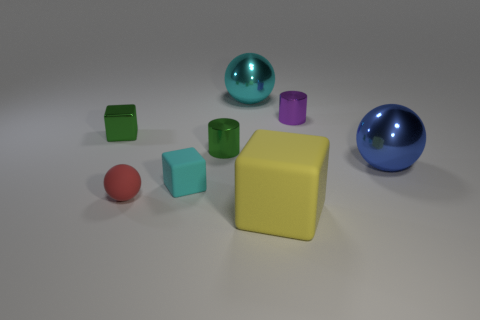Is the small cyan thing made of the same material as the large cube?
Keep it short and to the point. Yes. Is the number of big cyan things on the right side of the yellow object greater than the number of big yellow cubes?
Keep it short and to the point. No. What material is the tiny green thing behind the tiny green metallic thing that is to the right of the small cyan object in front of the cyan ball?
Offer a very short reply. Metal. What number of objects are either cubes or things to the left of the small purple cylinder?
Offer a terse response. 6. There is a big ball that is right of the yellow block; does it have the same color as the shiny block?
Ensure brevity in your answer.  No. Are there more blue shiny spheres that are in front of the red matte ball than small cyan rubber objects that are to the left of the blue ball?
Offer a terse response. No. Are there any other things that are the same color as the small metal block?
Offer a terse response. Yes. What number of objects are big blue rubber cylinders or green metal things?
Provide a short and direct response. 2. There is a ball that is on the right side of the yellow rubber thing; is its size the same as the small green metallic block?
Offer a terse response. No. How many other objects are there of the same size as the green cylinder?
Your response must be concise. 4. 